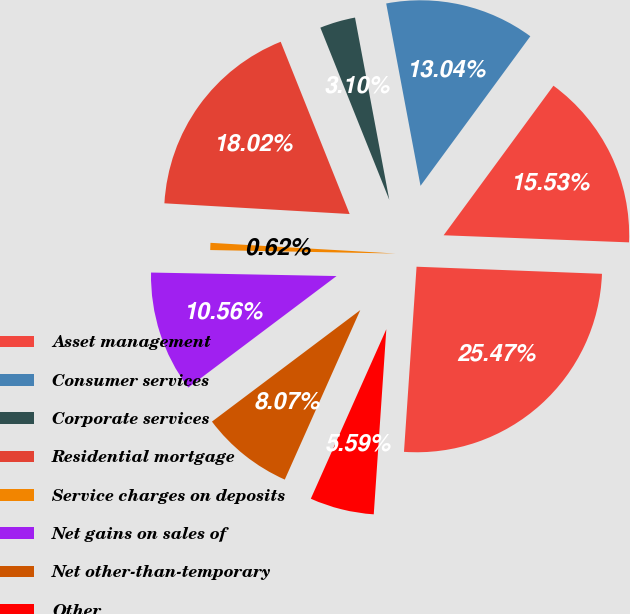Convert chart to OTSL. <chart><loc_0><loc_0><loc_500><loc_500><pie_chart><fcel>Asset management<fcel>Consumer services<fcel>Corporate services<fcel>Residential mortgage<fcel>Service charges on deposits<fcel>Net gains on sales of<fcel>Net other-than-temporary<fcel>Other<fcel>Total noninterest income<nl><fcel>15.53%<fcel>13.04%<fcel>3.1%<fcel>18.02%<fcel>0.62%<fcel>10.56%<fcel>8.07%<fcel>5.59%<fcel>25.47%<nl></chart> 